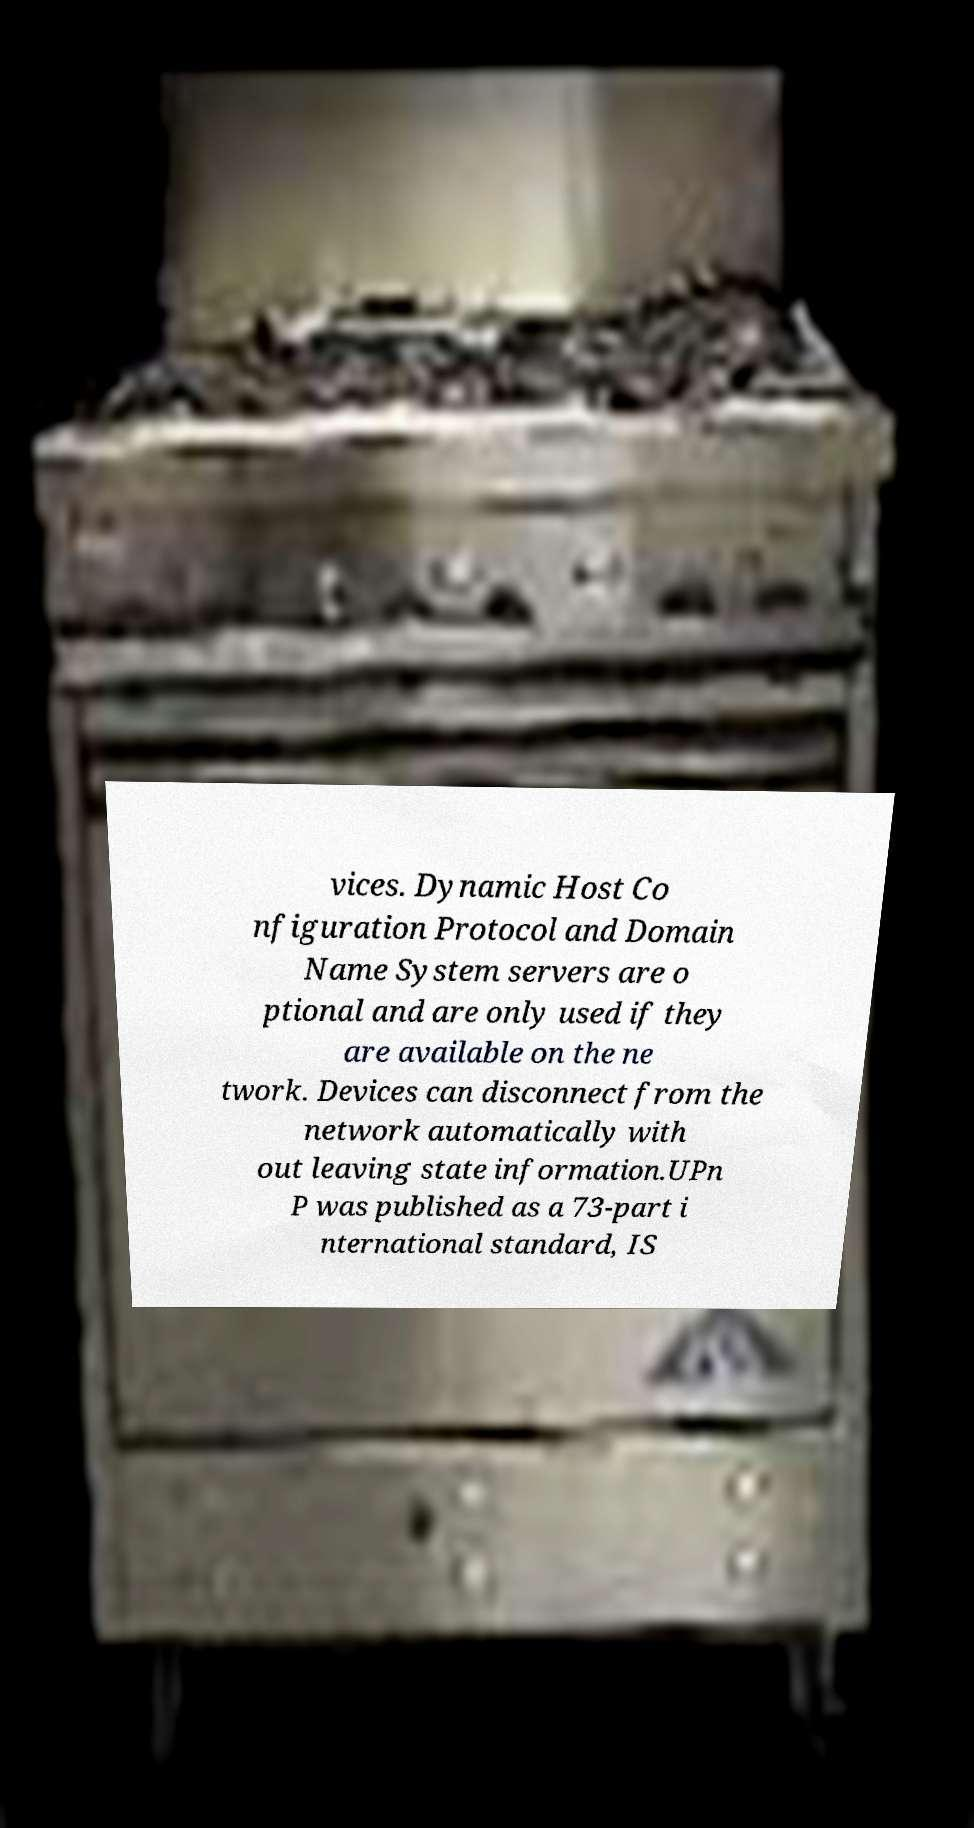There's text embedded in this image that I need extracted. Can you transcribe it verbatim? vices. Dynamic Host Co nfiguration Protocol and Domain Name System servers are o ptional and are only used if they are available on the ne twork. Devices can disconnect from the network automatically with out leaving state information.UPn P was published as a 73-part i nternational standard, IS 